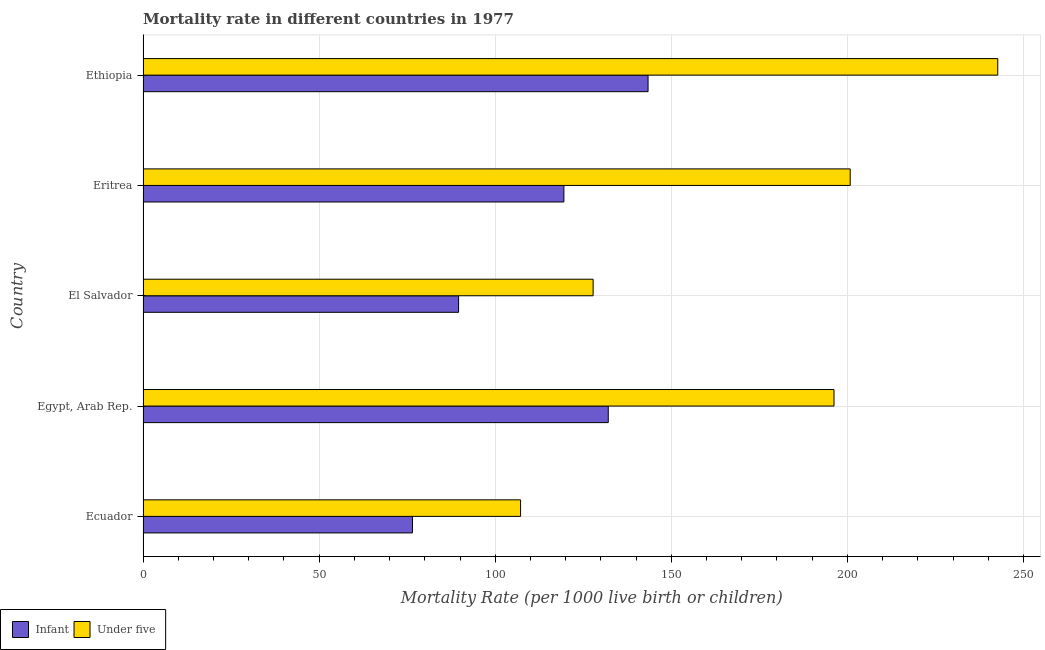Are the number of bars on each tick of the Y-axis equal?
Provide a succinct answer. Yes. What is the label of the 3rd group of bars from the top?
Give a very brief answer. El Salvador. In how many cases, is the number of bars for a given country not equal to the number of legend labels?
Provide a short and direct response. 0. What is the infant mortality rate in Egypt, Arab Rep.?
Give a very brief answer. 132.1. Across all countries, what is the maximum infant mortality rate?
Keep it short and to the point. 143.4. Across all countries, what is the minimum under-5 mortality rate?
Your answer should be very brief. 107.2. In which country was the infant mortality rate maximum?
Keep it short and to the point. Ethiopia. In which country was the under-5 mortality rate minimum?
Give a very brief answer. Ecuador. What is the total under-5 mortality rate in the graph?
Give a very brief answer. 874.7. What is the difference between the under-5 mortality rate in El Salvador and that in Ethiopia?
Keep it short and to the point. -114.9. What is the difference between the under-5 mortality rate in Eritrea and the infant mortality rate in Egypt, Arab Rep.?
Provide a short and direct response. 68.7. What is the average under-5 mortality rate per country?
Provide a succinct answer. 174.94. What is the difference between the infant mortality rate and under-5 mortality rate in El Salvador?
Ensure brevity in your answer.  -38.2. What is the ratio of the infant mortality rate in Ecuador to that in Ethiopia?
Offer a terse response. 0.53. What is the difference between the highest and the second highest infant mortality rate?
Ensure brevity in your answer.  11.3. What is the difference between the highest and the lowest under-5 mortality rate?
Your answer should be very brief. 135.5. What does the 2nd bar from the top in Egypt, Arab Rep. represents?
Offer a very short reply. Infant. What does the 2nd bar from the bottom in Ecuador represents?
Your answer should be very brief. Under five. How many bars are there?
Make the answer very short. 10. Are all the bars in the graph horizontal?
Ensure brevity in your answer.  Yes. How many countries are there in the graph?
Make the answer very short. 5. What is the difference between two consecutive major ticks on the X-axis?
Provide a succinct answer. 50. Are the values on the major ticks of X-axis written in scientific E-notation?
Provide a short and direct response. No. Does the graph contain any zero values?
Offer a very short reply. No. Where does the legend appear in the graph?
Give a very brief answer. Bottom left. How many legend labels are there?
Provide a succinct answer. 2. What is the title of the graph?
Offer a terse response. Mortality rate in different countries in 1977. Does "Official aid received" appear as one of the legend labels in the graph?
Give a very brief answer. No. What is the label or title of the X-axis?
Provide a succinct answer. Mortality Rate (per 1000 live birth or children). What is the label or title of the Y-axis?
Offer a very short reply. Country. What is the Mortality Rate (per 1000 live birth or children) of Infant in Ecuador?
Your answer should be compact. 76.5. What is the Mortality Rate (per 1000 live birth or children) in Under five in Ecuador?
Provide a short and direct response. 107.2. What is the Mortality Rate (per 1000 live birth or children) in Infant in Egypt, Arab Rep.?
Make the answer very short. 132.1. What is the Mortality Rate (per 1000 live birth or children) of Under five in Egypt, Arab Rep.?
Provide a succinct answer. 196.2. What is the Mortality Rate (per 1000 live birth or children) in Infant in El Salvador?
Your answer should be very brief. 89.6. What is the Mortality Rate (per 1000 live birth or children) in Under five in El Salvador?
Ensure brevity in your answer.  127.8. What is the Mortality Rate (per 1000 live birth or children) in Infant in Eritrea?
Give a very brief answer. 119.5. What is the Mortality Rate (per 1000 live birth or children) of Under five in Eritrea?
Your answer should be very brief. 200.8. What is the Mortality Rate (per 1000 live birth or children) of Infant in Ethiopia?
Provide a short and direct response. 143.4. What is the Mortality Rate (per 1000 live birth or children) of Under five in Ethiopia?
Your answer should be very brief. 242.7. Across all countries, what is the maximum Mortality Rate (per 1000 live birth or children) in Infant?
Offer a very short reply. 143.4. Across all countries, what is the maximum Mortality Rate (per 1000 live birth or children) in Under five?
Give a very brief answer. 242.7. Across all countries, what is the minimum Mortality Rate (per 1000 live birth or children) of Infant?
Your answer should be very brief. 76.5. Across all countries, what is the minimum Mortality Rate (per 1000 live birth or children) of Under five?
Keep it short and to the point. 107.2. What is the total Mortality Rate (per 1000 live birth or children) in Infant in the graph?
Provide a short and direct response. 561.1. What is the total Mortality Rate (per 1000 live birth or children) of Under five in the graph?
Ensure brevity in your answer.  874.7. What is the difference between the Mortality Rate (per 1000 live birth or children) of Infant in Ecuador and that in Egypt, Arab Rep.?
Your response must be concise. -55.6. What is the difference between the Mortality Rate (per 1000 live birth or children) of Under five in Ecuador and that in Egypt, Arab Rep.?
Your answer should be compact. -89. What is the difference between the Mortality Rate (per 1000 live birth or children) of Under five in Ecuador and that in El Salvador?
Your answer should be very brief. -20.6. What is the difference between the Mortality Rate (per 1000 live birth or children) in Infant in Ecuador and that in Eritrea?
Your response must be concise. -43. What is the difference between the Mortality Rate (per 1000 live birth or children) of Under five in Ecuador and that in Eritrea?
Provide a short and direct response. -93.6. What is the difference between the Mortality Rate (per 1000 live birth or children) in Infant in Ecuador and that in Ethiopia?
Provide a short and direct response. -66.9. What is the difference between the Mortality Rate (per 1000 live birth or children) in Under five in Ecuador and that in Ethiopia?
Give a very brief answer. -135.5. What is the difference between the Mortality Rate (per 1000 live birth or children) of Infant in Egypt, Arab Rep. and that in El Salvador?
Give a very brief answer. 42.5. What is the difference between the Mortality Rate (per 1000 live birth or children) in Under five in Egypt, Arab Rep. and that in El Salvador?
Ensure brevity in your answer.  68.4. What is the difference between the Mortality Rate (per 1000 live birth or children) of Under five in Egypt, Arab Rep. and that in Eritrea?
Keep it short and to the point. -4.6. What is the difference between the Mortality Rate (per 1000 live birth or children) of Infant in Egypt, Arab Rep. and that in Ethiopia?
Ensure brevity in your answer.  -11.3. What is the difference between the Mortality Rate (per 1000 live birth or children) of Under five in Egypt, Arab Rep. and that in Ethiopia?
Provide a short and direct response. -46.5. What is the difference between the Mortality Rate (per 1000 live birth or children) in Infant in El Salvador and that in Eritrea?
Provide a short and direct response. -29.9. What is the difference between the Mortality Rate (per 1000 live birth or children) in Under five in El Salvador and that in Eritrea?
Provide a succinct answer. -73. What is the difference between the Mortality Rate (per 1000 live birth or children) of Infant in El Salvador and that in Ethiopia?
Give a very brief answer. -53.8. What is the difference between the Mortality Rate (per 1000 live birth or children) of Under five in El Salvador and that in Ethiopia?
Provide a succinct answer. -114.9. What is the difference between the Mortality Rate (per 1000 live birth or children) of Infant in Eritrea and that in Ethiopia?
Ensure brevity in your answer.  -23.9. What is the difference between the Mortality Rate (per 1000 live birth or children) of Under five in Eritrea and that in Ethiopia?
Provide a short and direct response. -41.9. What is the difference between the Mortality Rate (per 1000 live birth or children) in Infant in Ecuador and the Mortality Rate (per 1000 live birth or children) in Under five in Egypt, Arab Rep.?
Keep it short and to the point. -119.7. What is the difference between the Mortality Rate (per 1000 live birth or children) of Infant in Ecuador and the Mortality Rate (per 1000 live birth or children) of Under five in El Salvador?
Keep it short and to the point. -51.3. What is the difference between the Mortality Rate (per 1000 live birth or children) in Infant in Ecuador and the Mortality Rate (per 1000 live birth or children) in Under five in Eritrea?
Keep it short and to the point. -124.3. What is the difference between the Mortality Rate (per 1000 live birth or children) in Infant in Ecuador and the Mortality Rate (per 1000 live birth or children) in Under five in Ethiopia?
Offer a very short reply. -166.2. What is the difference between the Mortality Rate (per 1000 live birth or children) of Infant in Egypt, Arab Rep. and the Mortality Rate (per 1000 live birth or children) of Under five in Eritrea?
Offer a very short reply. -68.7. What is the difference between the Mortality Rate (per 1000 live birth or children) in Infant in Egypt, Arab Rep. and the Mortality Rate (per 1000 live birth or children) in Under five in Ethiopia?
Give a very brief answer. -110.6. What is the difference between the Mortality Rate (per 1000 live birth or children) of Infant in El Salvador and the Mortality Rate (per 1000 live birth or children) of Under five in Eritrea?
Your response must be concise. -111.2. What is the difference between the Mortality Rate (per 1000 live birth or children) in Infant in El Salvador and the Mortality Rate (per 1000 live birth or children) in Under five in Ethiopia?
Your answer should be compact. -153.1. What is the difference between the Mortality Rate (per 1000 live birth or children) of Infant in Eritrea and the Mortality Rate (per 1000 live birth or children) of Under five in Ethiopia?
Your answer should be compact. -123.2. What is the average Mortality Rate (per 1000 live birth or children) of Infant per country?
Your response must be concise. 112.22. What is the average Mortality Rate (per 1000 live birth or children) of Under five per country?
Give a very brief answer. 174.94. What is the difference between the Mortality Rate (per 1000 live birth or children) of Infant and Mortality Rate (per 1000 live birth or children) of Under five in Ecuador?
Provide a succinct answer. -30.7. What is the difference between the Mortality Rate (per 1000 live birth or children) in Infant and Mortality Rate (per 1000 live birth or children) in Under five in Egypt, Arab Rep.?
Your answer should be compact. -64.1. What is the difference between the Mortality Rate (per 1000 live birth or children) of Infant and Mortality Rate (per 1000 live birth or children) of Under five in El Salvador?
Keep it short and to the point. -38.2. What is the difference between the Mortality Rate (per 1000 live birth or children) of Infant and Mortality Rate (per 1000 live birth or children) of Under five in Eritrea?
Provide a short and direct response. -81.3. What is the difference between the Mortality Rate (per 1000 live birth or children) of Infant and Mortality Rate (per 1000 live birth or children) of Under five in Ethiopia?
Your answer should be very brief. -99.3. What is the ratio of the Mortality Rate (per 1000 live birth or children) of Infant in Ecuador to that in Egypt, Arab Rep.?
Ensure brevity in your answer.  0.58. What is the ratio of the Mortality Rate (per 1000 live birth or children) of Under five in Ecuador to that in Egypt, Arab Rep.?
Provide a short and direct response. 0.55. What is the ratio of the Mortality Rate (per 1000 live birth or children) in Infant in Ecuador to that in El Salvador?
Provide a short and direct response. 0.85. What is the ratio of the Mortality Rate (per 1000 live birth or children) of Under five in Ecuador to that in El Salvador?
Provide a short and direct response. 0.84. What is the ratio of the Mortality Rate (per 1000 live birth or children) of Infant in Ecuador to that in Eritrea?
Offer a very short reply. 0.64. What is the ratio of the Mortality Rate (per 1000 live birth or children) of Under five in Ecuador to that in Eritrea?
Your answer should be compact. 0.53. What is the ratio of the Mortality Rate (per 1000 live birth or children) of Infant in Ecuador to that in Ethiopia?
Your answer should be very brief. 0.53. What is the ratio of the Mortality Rate (per 1000 live birth or children) in Under five in Ecuador to that in Ethiopia?
Keep it short and to the point. 0.44. What is the ratio of the Mortality Rate (per 1000 live birth or children) of Infant in Egypt, Arab Rep. to that in El Salvador?
Your answer should be very brief. 1.47. What is the ratio of the Mortality Rate (per 1000 live birth or children) in Under five in Egypt, Arab Rep. to that in El Salvador?
Your response must be concise. 1.54. What is the ratio of the Mortality Rate (per 1000 live birth or children) of Infant in Egypt, Arab Rep. to that in Eritrea?
Offer a very short reply. 1.11. What is the ratio of the Mortality Rate (per 1000 live birth or children) in Under five in Egypt, Arab Rep. to that in Eritrea?
Ensure brevity in your answer.  0.98. What is the ratio of the Mortality Rate (per 1000 live birth or children) of Infant in Egypt, Arab Rep. to that in Ethiopia?
Give a very brief answer. 0.92. What is the ratio of the Mortality Rate (per 1000 live birth or children) in Under five in Egypt, Arab Rep. to that in Ethiopia?
Provide a short and direct response. 0.81. What is the ratio of the Mortality Rate (per 1000 live birth or children) of Infant in El Salvador to that in Eritrea?
Keep it short and to the point. 0.75. What is the ratio of the Mortality Rate (per 1000 live birth or children) of Under five in El Salvador to that in Eritrea?
Your answer should be very brief. 0.64. What is the ratio of the Mortality Rate (per 1000 live birth or children) in Infant in El Salvador to that in Ethiopia?
Your answer should be very brief. 0.62. What is the ratio of the Mortality Rate (per 1000 live birth or children) of Under five in El Salvador to that in Ethiopia?
Keep it short and to the point. 0.53. What is the ratio of the Mortality Rate (per 1000 live birth or children) of Infant in Eritrea to that in Ethiopia?
Offer a terse response. 0.83. What is the ratio of the Mortality Rate (per 1000 live birth or children) of Under five in Eritrea to that in Ethiopia?
Keep it short and to the point. 0.83. What is the difference between the highest and the second highest Mortality Rate (per 1000 live birth or children) of Infant?
Your answer should be compact. 11.3. What is the difference between the highest and the second highest Mortality Rate (per 1000 live birth or children) in Under five?
Give a very brief answer. 41.9. What is the difference between the highest and the lowest Mortality Rate (per 1000 live birth or children) in Infant?
Provide a succinct answer. 66.9. What is the difference between the highest and the lowest Mortality Rate (per 1000 live birth or children) of Under five?
Keep it short and to the point. 135.5. 